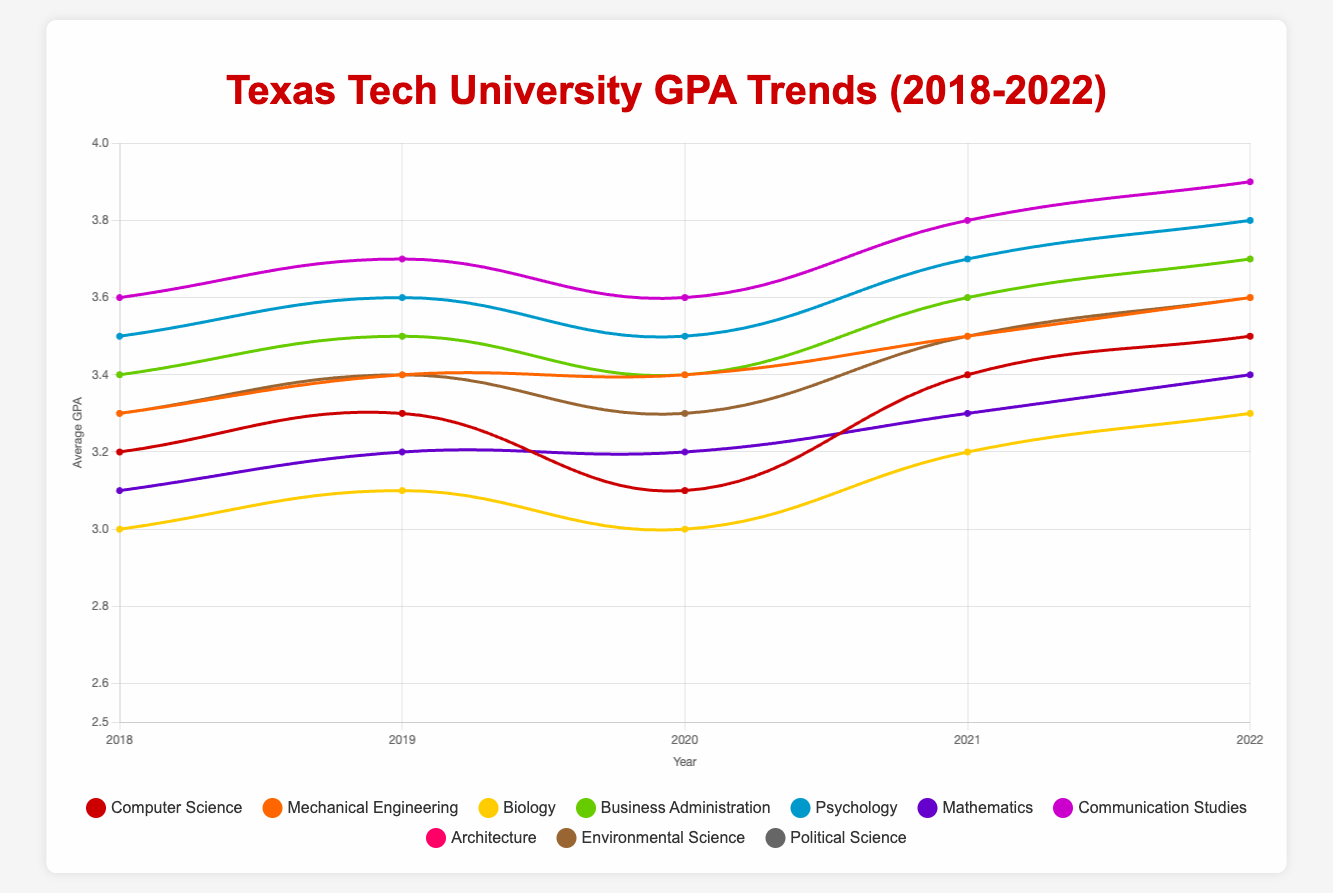Which major had the lowest average GPA in 2018? To find the answer, look at the GPA values for each major in 2018. The lowest one is 3.0, which is for Biology.
Answer: Biology How did the average GPA for Computer Science change between 2018 and 2022? Compare the GPA values for Computer Science from 2018 (3.2) to 2022 (3.5). The GPA increased by 0.3 points.
Answer: Increased by 0.3 points Which year had the highest average GPA for Communication Studies? Check the GPA values for Communication Studies over the years. The highest GPA is 3.9, which occurred in 2022.
Answer: 2022 What's the average GPA of Business Administration over the years 2018-2022? To calculate the average GPA, sum the GPAs for Business Administration from 2018 (3.4), 2019 (3.5), 2020 (3.4), 2021 (3.6), and 2022 (3.7). The sum is 17.6, divided by 5 gives an average of 3.52.
Answer: 3.52 Compare the GPA trends for Psychology and Mathematics from 2018 to 2022. Which major showed a more significant improvement? Look at the GPA changes for both majors. Psychology increased from 3.5 to 3.8 (0.3 points), while Mathematics increased from 3.1 to 3.4 (0.3 points). They both improved equally by 0.3 points.
Answer: Both improved equally In which year did Mechanical Engineering have the same average GPA as Architecture? Check the GPA values for Mechanical Engineering and Architecture. In 2020, both had an average GPA of 3.4.
Answer: 2020 Which major consistently had a GPA above 3.5 across all years? Communication Studies had GPAs of 3.6, 3.7, 3.6, 3.8, and 3.9 from 2018 to 2022, consistently above 3.5.
Answer: Communication Studies What is the visual trend of the average GPA for Political Science? The average GPA for Political Science steadily increased from 3.4 in 2018 to 3.7 in 2022.
Answer: Steady increase Between 2018 and 2022, which year did Environmental Science see the highest increase in GPA? From 2018 to 2022, the GPAs for Environmental Science are as follows: 3.3, 3.4, 3.3, 3.5, and 3.6. The highest increase occurred between 2020 (3.3) and 2021 (3.5), an increase of 0.2 points.
Answer: 2021 Compare the average GPA of Biology in 2018 and Architecture in 2022. Which is higher? The average GPA for Biology in 2018 is 3.0, and for Architecture in 2022 is 3.5. The average GPA for Architecture in 2022 is higher.
Answer: Architecture in 2022 